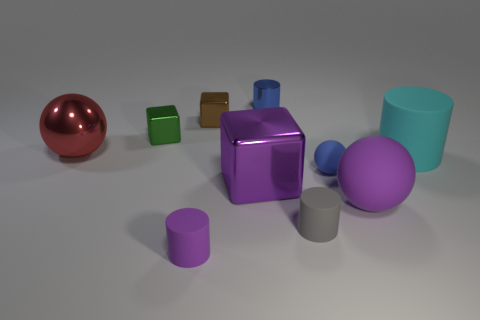Are there any small blue metal things that have the same shape as the green object? No, there are no small blue metal objects with the exact same shape as the green object depicted in the image. However, there are blue objects that share a similarity in being geometric shapes like the green ones. 